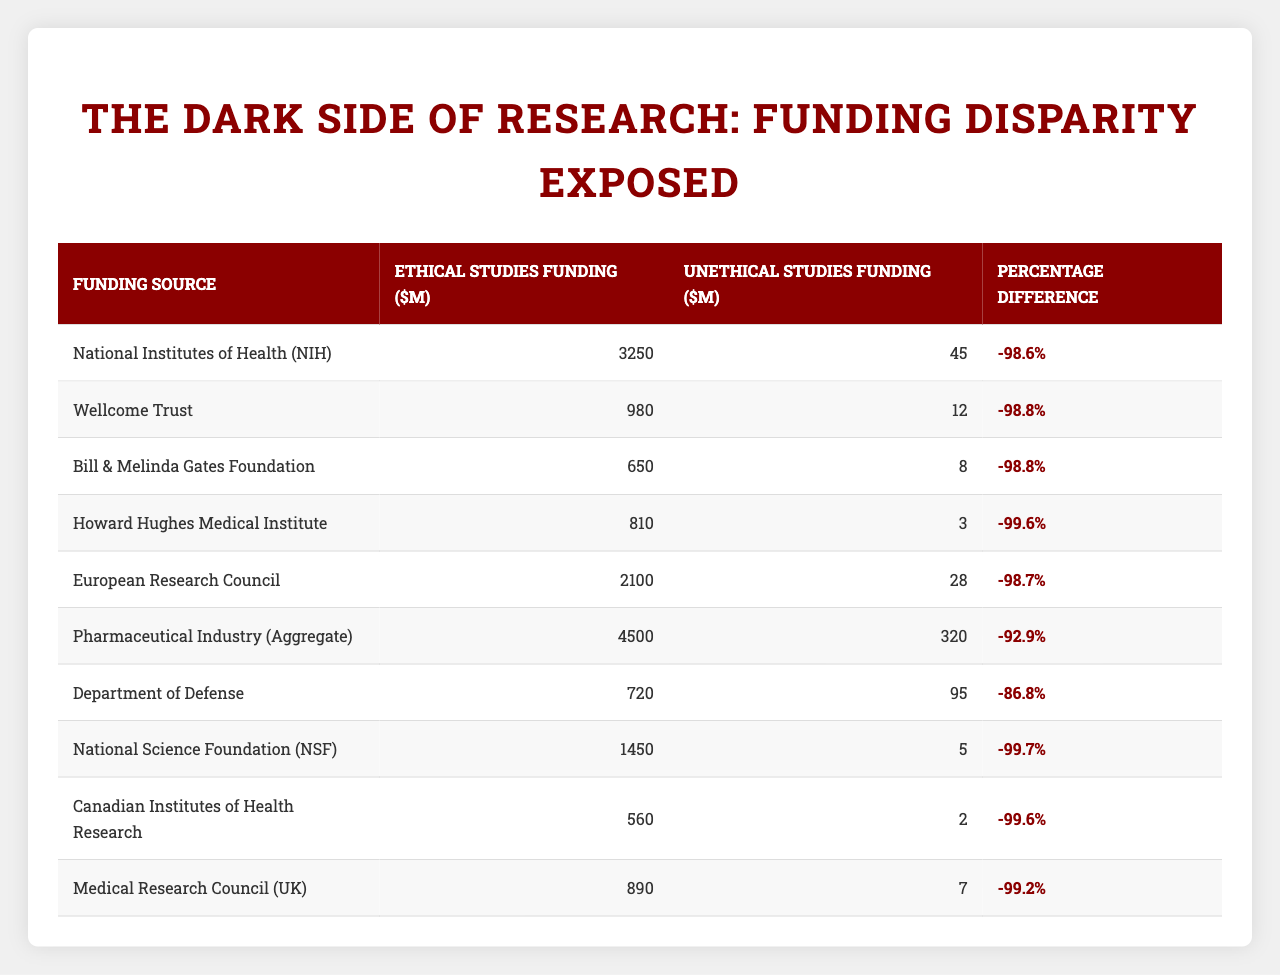What is the funding amount for ethical studies from the National Institutes of Health (NIH)? The second column of the table indicates that the funding amount for ethical studies from NIH is $3,250 million.
Answer: $3,250 million How much funding was allocated to unethical studies by the Pharmaceutical Industry? According to the table, the funding amount for unethical studies by the Pharmaceutical Industry is $320 million as provided in the third column.
Answer: $320 million What is the total funding for ethical studies from the listed funding sources? Summing the values in the second column gives: $3,250M (NIH) + $980M (Wellcome Trust) + $650M (Bill & Melinda Gates Foundation) + $810M (Howard Hughes Medical Institute) + $2,100M (European Research Council) + $4,500M (Pharmaceutical Industry) + $720M (Department of Defense) + $1,450M (NSF) + $560M (Canadian Institutes of Health Research) + $890M (Medical Research Council) = $15,610 million.
Answer: $15,610 million Is the funding for unethical studies from the Wellcome Trust higher than that from the Department of Defense? The values from the table indicate that the funding for unethical studies from Wellcome Trust is $12 million, while from the Department of Defense it is $95 million, so the statement is false.
Answer: No Which funding source has the largest percentage difference between ethical and unethical study funding? By comparing the percentage differences in the last column, the largest difference is from the Howard Hughes Medical Institute at -99.6%, which is the most significant disparity indicating major funding for ethical studies versus unethical studies.
Answer: Howard Hughes Medical Institute What is the average funding for unethical studies across all listed funding sources? The total unethical funding is the sum of the third column values: $45M + $12M + $8M + $3M + $28M + $320M + $95M + $5M + $2M + $7M = $520 million. Since there are 10 sources, the average is $520M / 10 = $52 million.
Answer: $52 million Which has more overall funding: ethical studies or unethical studies? Comparing the total amounts: ethical studies total $15,610 million, while unethical studies total $520 million. Since 15,610 million is greater than 520 million, ethical studies have more funding.
Answer: Ethical studies How does the funding for unethical studies from the National Science Foundation compare to the Canadian Institutes of Health Research? The NSF has $5 million for unethical studies while the Canadian Institutes has $2 million for unethical studies. Since $5 million is greater than $2 million, the NSF has more funding for unethical studies.
Answer: NSF has more funding What percentage difference is there between ethical and unethical funding from the European Research Council? According to the table, the funding for ethical studies from the European Research Council is $2100 million and for unethical is $28 million. The percentage difference is calculated as ((2100 - 28) / 2100) * 100 = 98.7%.
Answer: 98.7% 